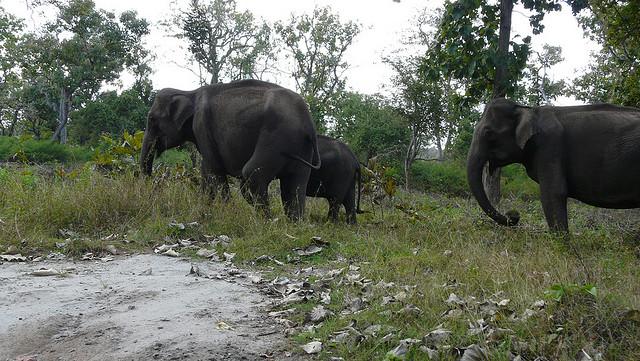How many bananas are in the bundle?
Quick response, please. 0. How many baby elephants are there?
Short answer required. 1. Are these animals in the wild?
Concise answer only. Yes. Are there any stones on the ground?
Answer briefly. Yes. How many elephants are there?
Concise answer only. 3. What would this elephant be poached for?
Concise answer only. Nothing. How many animals are shown?
Short answer required. 3. Is this a city?
Quick response, please. No. 